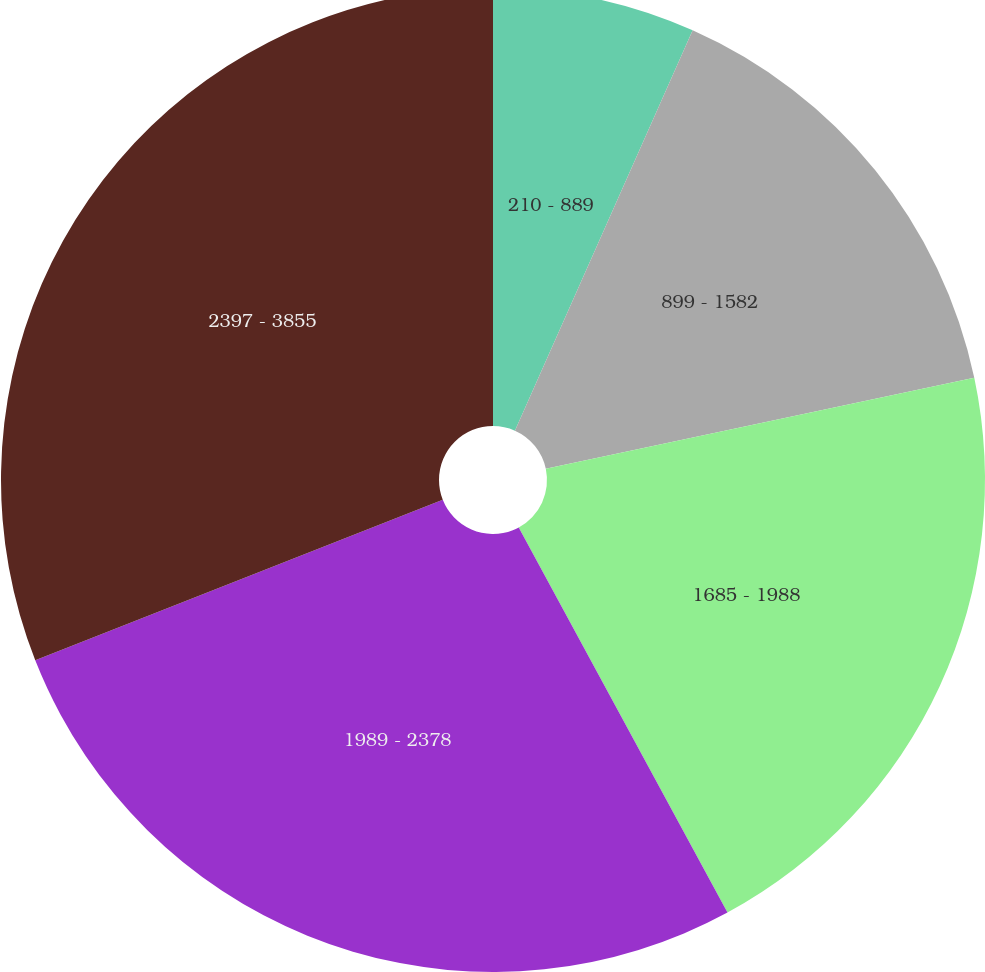Convert chart. <chart><loc_0><loc_0><loc_500><loc_500><pie_chart><fcel>210 - 889<fcel>899 - 1582<fcel>1685 - 1988<fcel>1989 - 2378<fcel>2397 - 3855<nl><fcel>6.65%<fcel>15.02%<fcel>20.42%<fcel>26.93%<fcel>30.97%<nl></chart> 